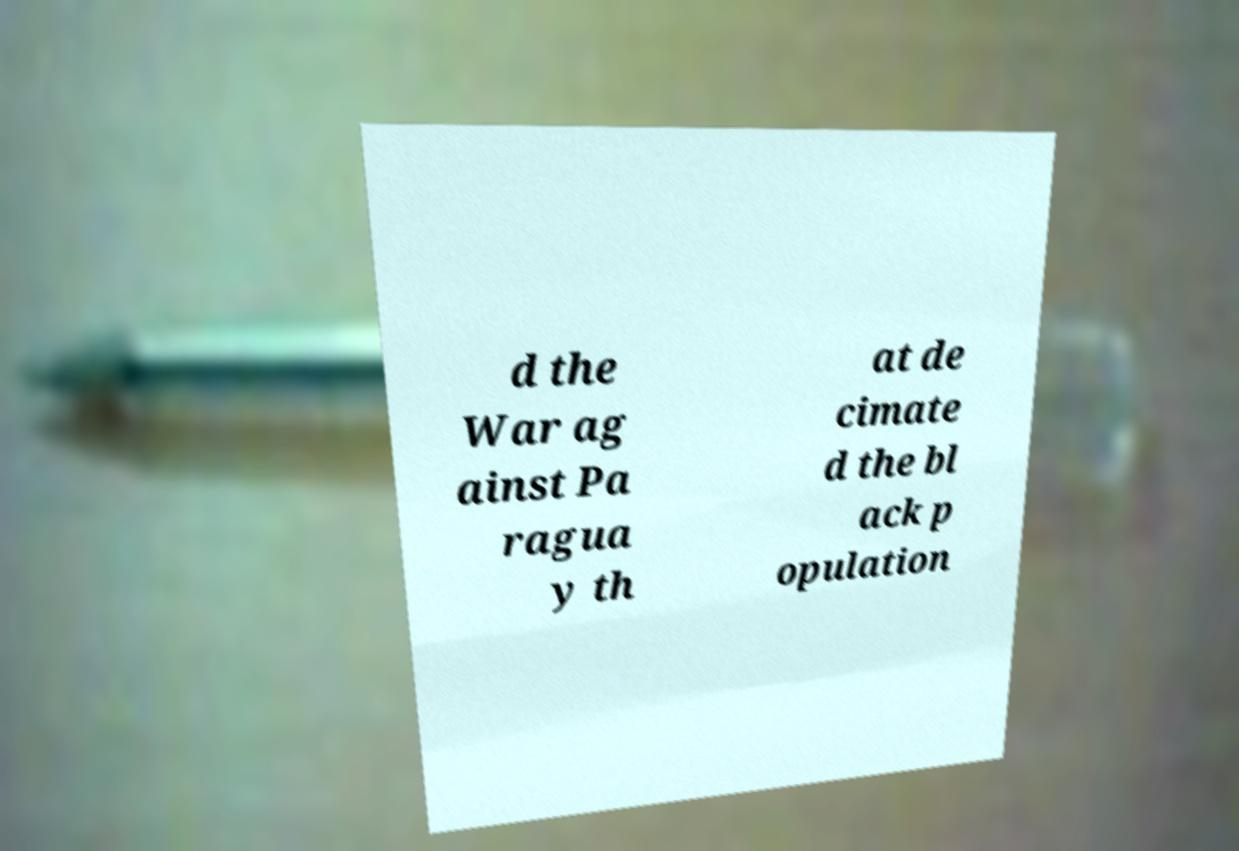Can you read and provide the text displayed in the image?This photo seems to have some interesting text. Can you extract and type it out for me? d the War ag ainst Pa ragua y th at de cimate d the bl ack p opulation 